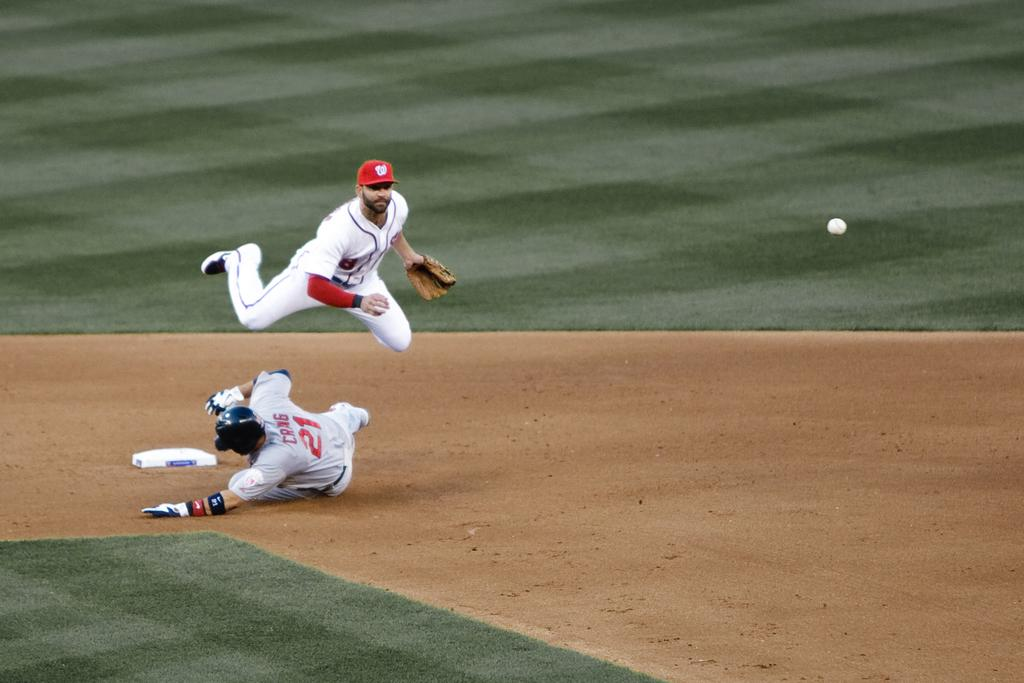<image>
Give a short and clear explanation of the subsequent image. Two baseball players, one with the number 21 on his shirt. 